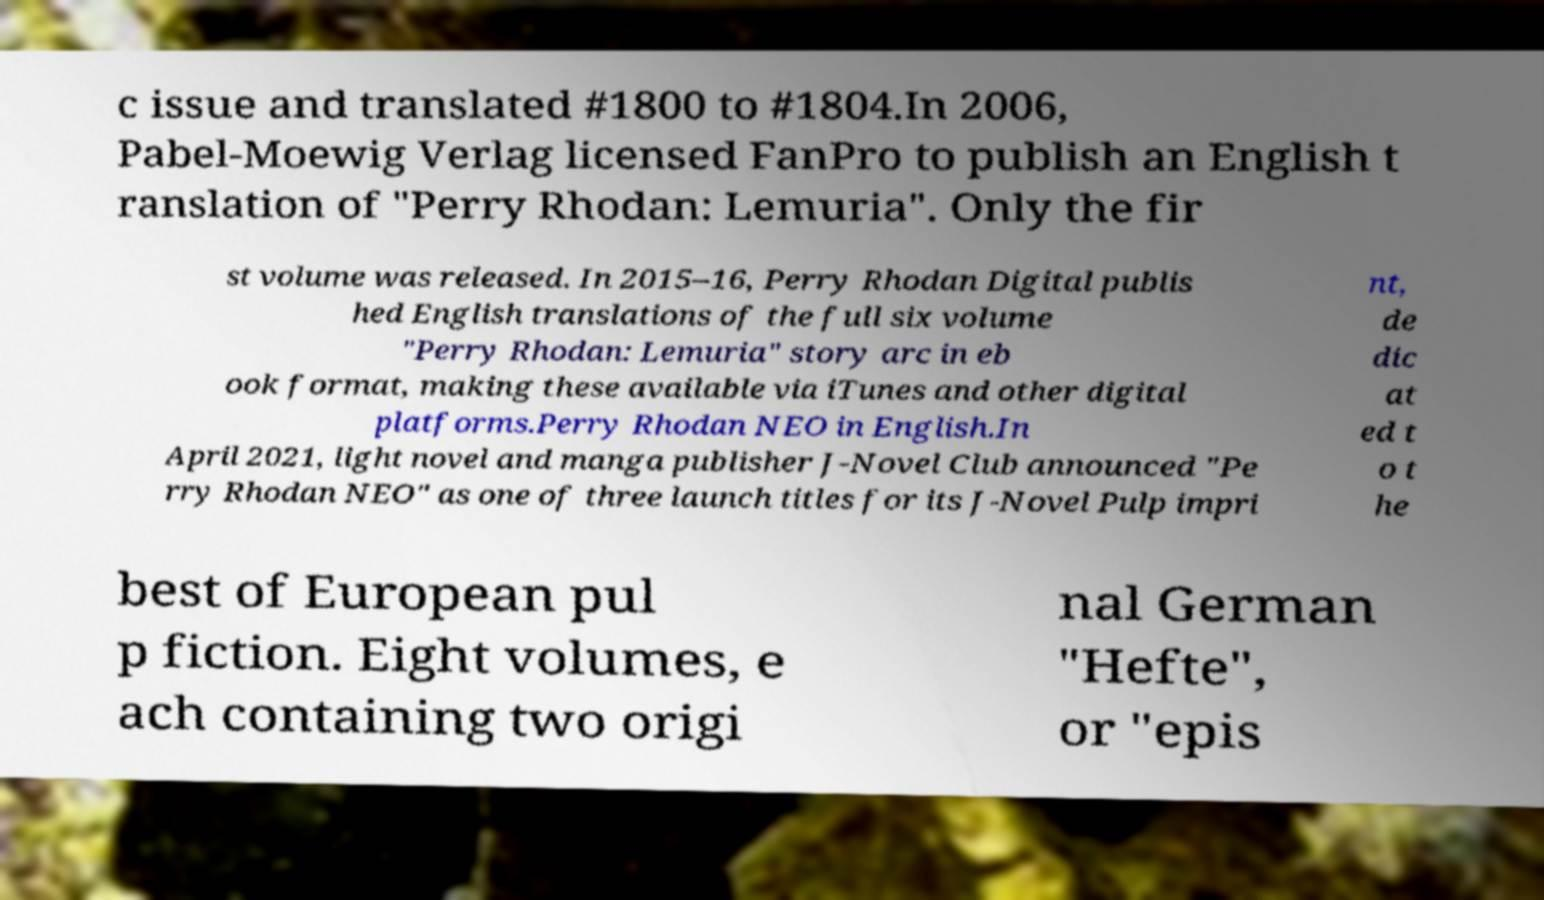What messages or text are displayed in this image? I need them in a readable, typed format. c issue and translated #1800 to #1804.In 2006, Pabel-Moewig Verlag licensed FanPro to publish an English t ranslation of "Perry Rhodan: Lemuria". Only the fir st volume was released. In 2015–16, Perry Rhodan Digital publis hed English translations of the full six volume "Perry Rhodan: Lemuria" story arc in eb ook format, making these available via iTunes and other digital platforms.Perry Rhodan NEO in English.In April 2021, light novel and manga publisher J-Novel Club announced "Pe rry Rhodan NEO" as one of three launch titles for its J-Novel Pulp impri nt, de dic at ed t o t he best of European pul p fiction. Eight volumes, e ach containing two origi nal German "Hefte", or "epis 